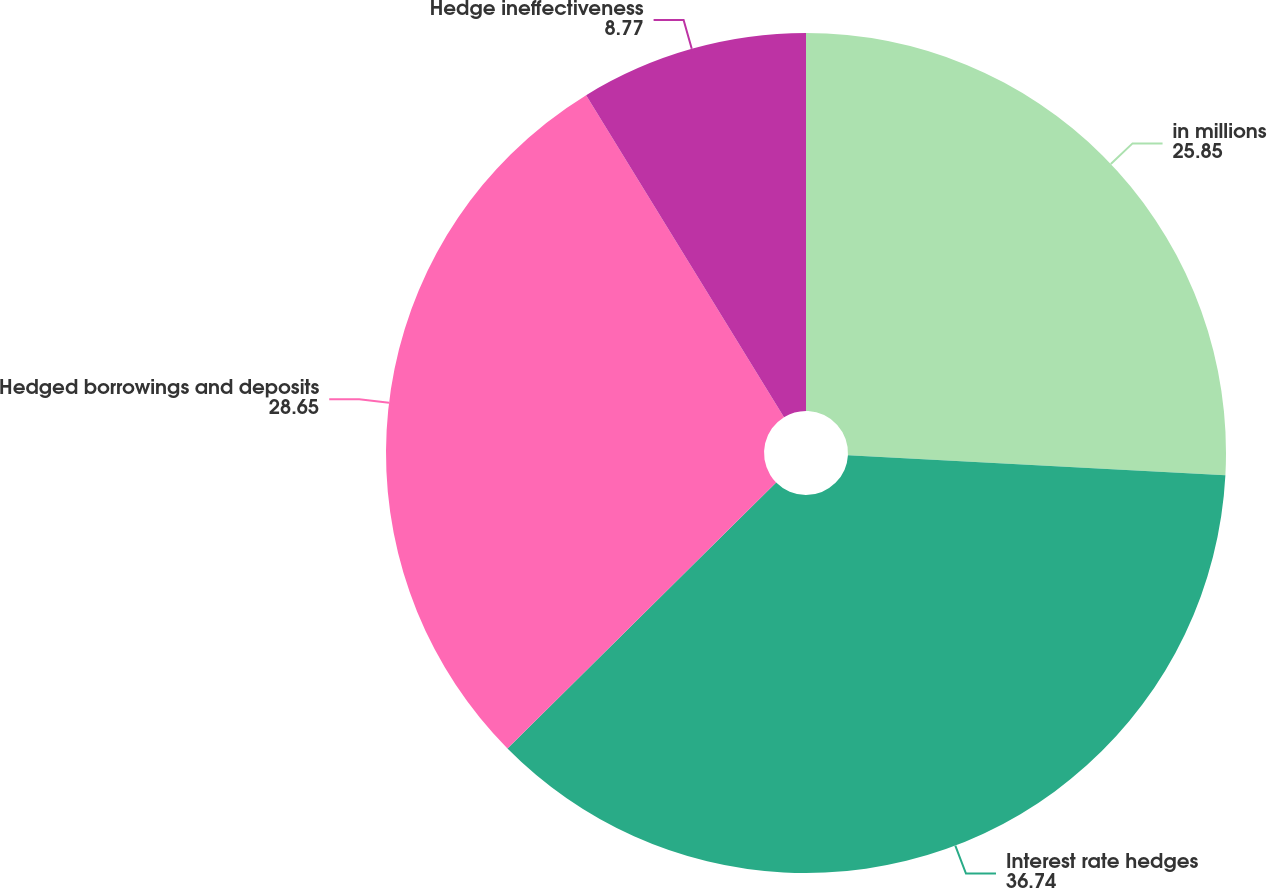<chart> <loc_0><loc_0><loc_500><loc_500><pie_chart><fcel>in millions<fcel>Interest rate hedges<fcel>Hedged borrowings and deposits<fcel>Hedge ineffectiveness<nl><fcel>25.85%<fcel>36.74%<fcel>28.65%<fcel>8.77%<nl></chart> 